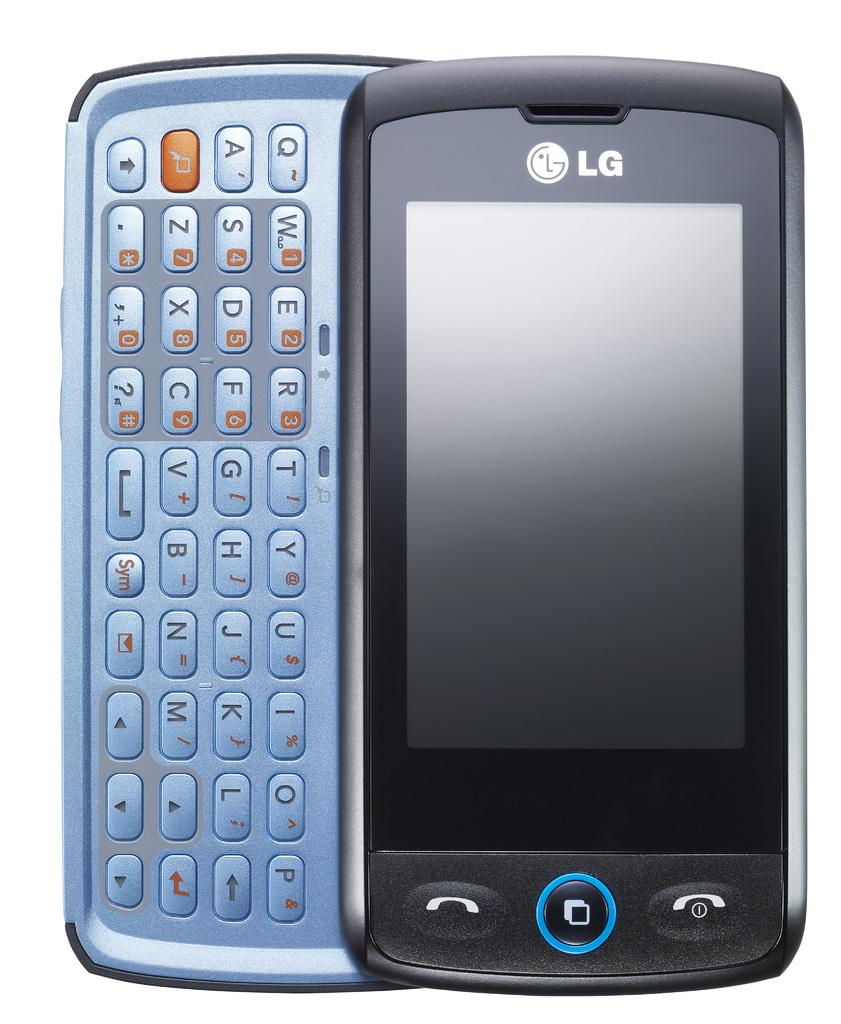<image>
Provide a brief description of the given image. An LG phone with a slide out QWERTY keyboard. 